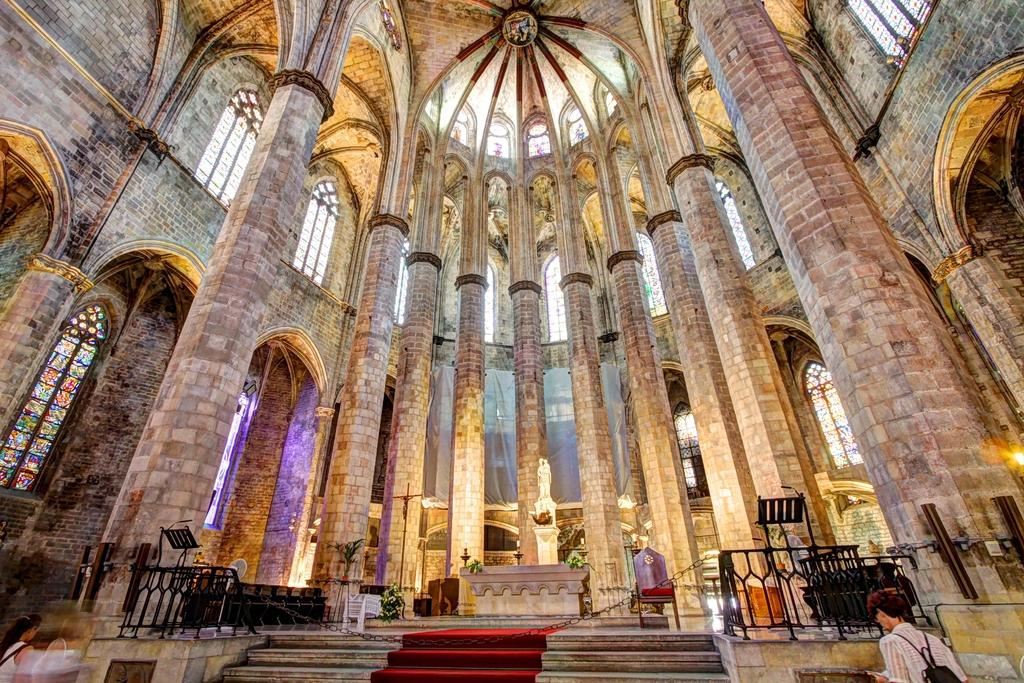What architectural feature is located in the middle of the image? There are pillars in the middle of the image. What can be seen at the bottom of the image? There are steps at the bottom of the image. How many people are visible in the image? There are two people visible in the image, one in the bottom left and one in the bottom right. What type of meal is being prepared by the person in the bottom left of the image? There is no indication of a meal or any cooking activity in the image. 